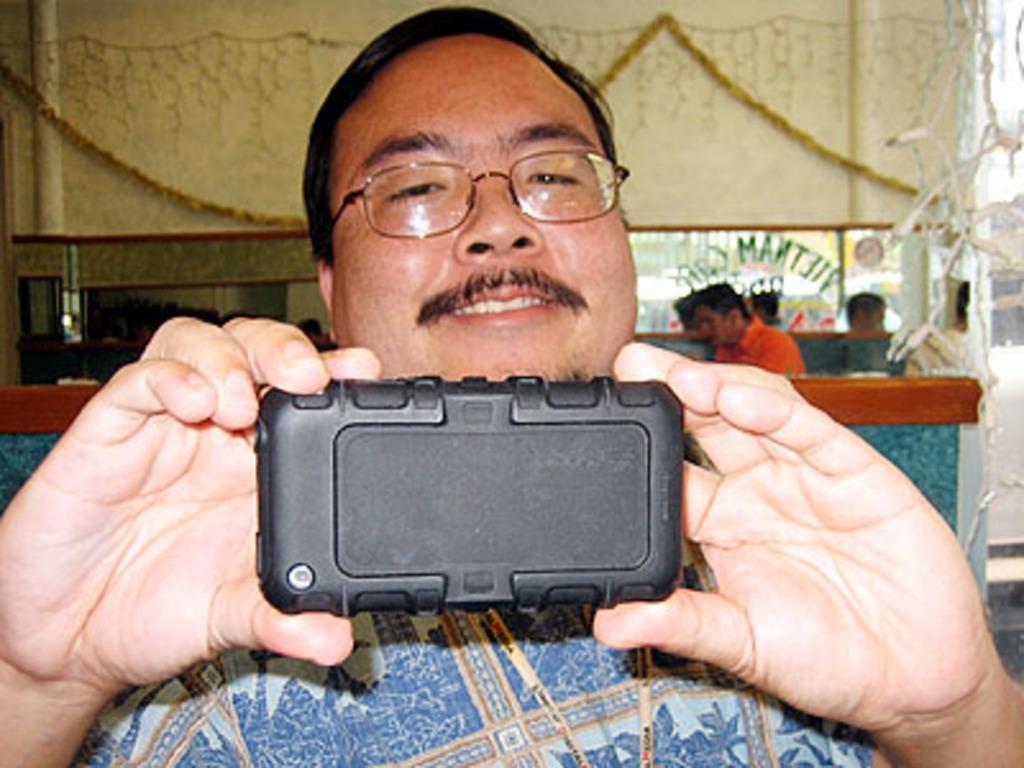Can you describe this image briefly? In this picture I can see there is a man standing and he is wearing a shirt and spectacles. He is holding a mobile phone and in the backdrop, there are a few people standing and there is a wall in the backdrop, with the decoration. 